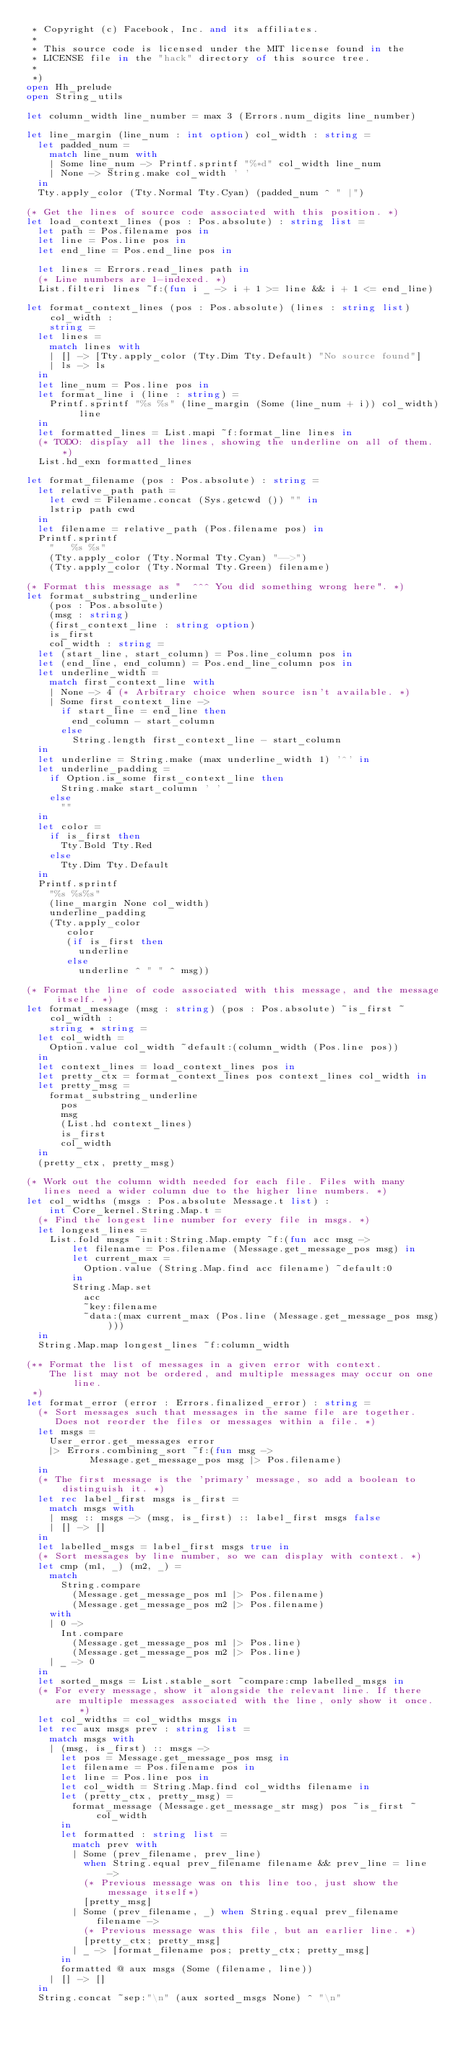<code> <loc_0><loc_0><loc_500><loc_500><_OCaml_> * Copyright (c) Facebook, Inc. and its affiliates.
 *
 * This source code is licensed under the MIT license found in the
 * LICENSE file in the "hack" directory of this source tree.
 *
 *)
open Hh_prelude
open String_utils

let column_width line_number = max 3 (Errors.num_digits line_number)

let line_margin (line_num : int option) col_width : string =
  let padded_num =
    match line_num with
    | Some line_num -> Printf.sprintf "%*d" col_width line_num
    | None -> String.make col_width ' '
  in
  Tty.apply_color (Tty.Normal Tty.Cyan) (padded_num ^ " |")

(* Get the lines of source code associated with this position. *)
let load_context_lines (pos : Pos.absolute) : string list =
  let path = Pos.filename pos in
  let line = Pos.line pos in
  let end_line = Pos.end_line pos in

  let lines = Errors.read_lines path in
  (* Line numbers are 1-indexed. *)
  List.filteri lines ~f:(fun i _ -> i + 1 >= line && i + 1 <= end_line)

let format_context_lines (pos : Pos.absolute) (lines : string list) col_width :
    string =
  let lines =
    match lines with
    | [] -> [Tty.apply_color (Tty.Dim Tty.Default) "No source found"]
    | ls -> ls
  in
  let line_num = Pos.line pos in
  let format_line i (line : string) =
    Printf.sprintf "%s %s" (line_margin (Some (line_num + i)) col_width) line
  in
  let formatted_lines = List.mapi ~f:format_line lines in
  (* TODO: display all the lines, showing the underline on all of them. *)
  List.hd_exn formatted_lines

let format_filename (pos : Pos.absolute) : string =
  let relative_path path =
    let cwd = Filename.concat (Sys.getcwd ()) "" in
    lstrip path cwd
  in
  let filename = relative_path (Pos.filename pos) in
  Printf.sprintf
    "   %s %s"
    (Tty.apply_color (Tty.Normal Tty.Cyan) "-->")
    (Tty.apply_color (Tty.Normal Tty.Green) filename)

(* Format this message as "  ^^^ You did something wrong here". *)
let format_substring_underline
    (pos : Pos.absolute)
    (msg : string)
    (first_context_line : string option)
    is_first
    col_width : string =
  let (start_line, start_column) = Pos.line_column pos in
  let (end_line, end_column) = Pos.end_line_column pos in
  let underline_width =
    match first_context_line with
    | None -> 4 (* Arbitrary choice when source isn't available. *)
    | Some first_context_line ->
      if start_line = end_line then
        end_column - start_column
      else
        String.length first_context_line - start_column
  in
  let underline = String.make (max underline_width 1) '^' in
  let underline_padding =
    if Option.is_some first_context_line then
      String.make start_column ' '
    else
      ""
  in
  let color =
    if is_first then
      Tty.Bold Tty.Red
    else
      Tty.Dim Tty.Default
  in
  Printf.sprintf
    "%s %s%s"
    (line_margin None col_width)
    underline_padding
    (Tty.apply_color
       color
       (if is_first then
         underline
       else
         underline ^ " " ^ msg))

(* Format the line of code associated with this message, and the message itself. *)
let format_message (msg : string) (pos : Pos.absolute) ~is_first ~col_width :
    string * string =
  let col_width =
    Option.value col_width ~default:(column_width (Pos.line pos))
  in
  let context_lines = load_context_lines pos in
  let pretty_ctx = format_context_lines pos context_lines col_width in
  let pretty_msg =
    format_substring_underline
      pos
      msg
      (List.hd context_lines)
      is_first
      col_width
  in
  (pretty_ctx, pretty_msg)

(* Work out the column width needed for each file. Files with many
   lines need a wider column due to the higher line numbers. *)
let col_widths (msgs : Pos.absolute Message.t list) :
    int Core_kernel.String.Map.t =
  (* Find the longest line number for every file in msgs. *)
  let longest_lines =
    List.fold msgs ~init:String.Map.empty ~f:(fun acc msg ->
        let filename = Pos.filename (Message.get_message_pos msg) in
        let current_max =
          Option.value (String.Map.find acc filename) ~default:0
        in
        String.Map.set
          acc
          ~key:filename
          ~data:(max current_max (Pos.line (Message.get_message_pos msg))))
  in
  String.Map.map longest_lines ~f:column_width

(** Format the list of messages in a given error with context.
    The list may not be ordered, and multiple messages may occur on one line.
 *)
let format_error (error : Errors.finalized_error) : string =
  (* Sort messages such that messages in the same file are together.
     Does not reorder the files or messages within a file. *)
  let msgs =
    User_error.get_messages error
    |> Errors.combining_sort ~f:(fun msg ->
           Message.get_message_pos msg |> Pos.filename)
  in
  (* The first message is the 'primary' message, so add a boolean to distinguish it. *)
  let rec label_first msgs is_first =
    match msgs with
    | msg :: msgs -> (msg, is_first) :: label_first msgs false
    | [] -> []
  in
  let labelled_msgs = label_first msgs true in
  (* Sort messages by line number, so we can display with context. *)
  let cmp (m1, _) (m2, _) =
    match
      String.compare
        (Message.get_message_pos m1 |> Pos.filename)
        (Message.get_message_pos m2 |> Pos.filename)
    with
    | 0 ->
      Int.compare
        (Message.get_message_pos m1 |> Pos.line)
        (Message.get_message_pos m2 |> Pos.line)
    | _ -> 0
  in
  let sorted_msgs = List.stable_sort ~compare:cmp labelled_msgs in
  (* For every message, show it alongside the relevant line. If there
     are multiple messages associated with the line, only show it once. *)
  let col_widths = col_widths msgs in
  let rec aux msgs prev : string list =
    match msgs with
    | (msg, is_first) :: msgs ->
      let pos = Message.get_message_pos msg in
      let filename = Pos.filename pos in
      let line = Pos.line pos in
      let col_width = String.Map.find col_widths filename in
      let (pretty_ctx, pretty_msg) =
        format_message (Message.get_message_str msg) pos ~is_first ~col_width
      in
      let formatted : string list =
        match prev with
        | Some (prev_filename, prev_line)
          when String.equal prev_filename filename && prev_line = line ->
          (* Previous message was on this line too, just show the message itself*)
          [pretty_msg]
        | Some (prev_filename, _) when String.equal prev_filename filename ->
          (* Previous message was this file, but an earlier line. *)
          [pretty_ctx; pretty_msg]
        | _ -> [format_filename pos; pretty_ctx; pretty_msg]
      in
      formatted @ aux msgs (Some (filename, line))
    | [] -> []
  in
  String.concat ~sep:"\n" (aux sorted_msgs None) ^ "\n"
</code> 